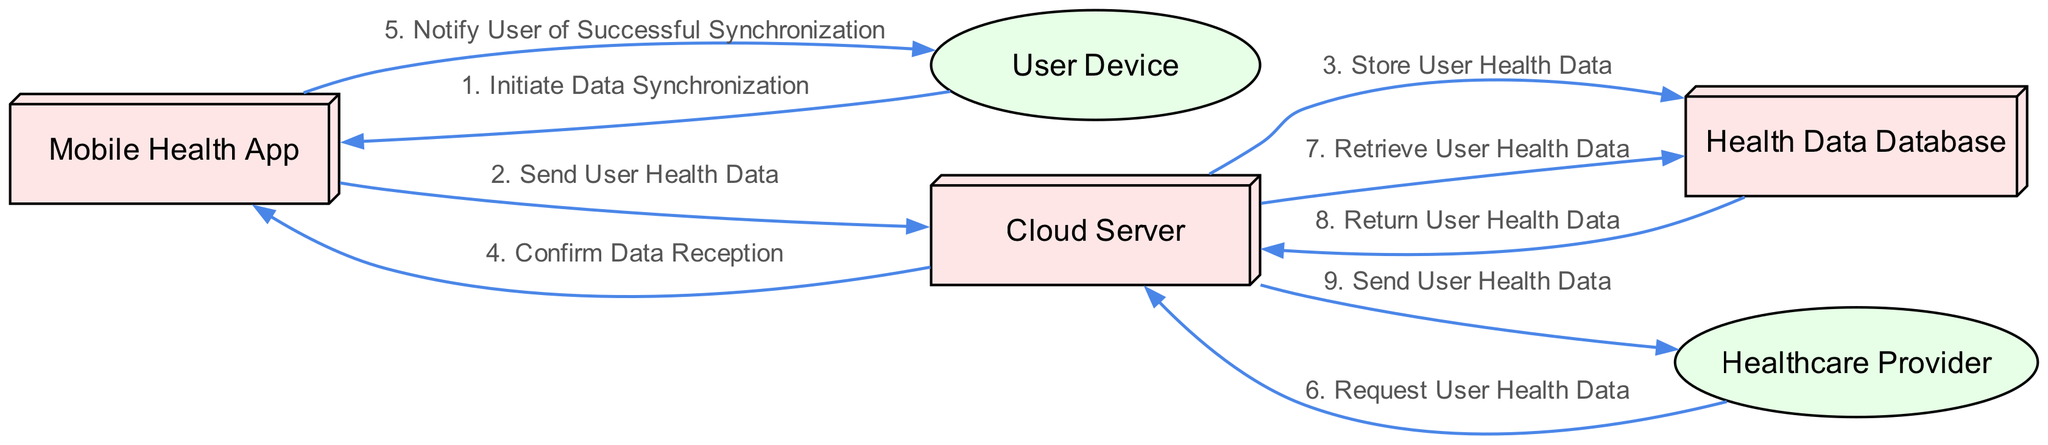What is the first action in the sequence? The first action in the sequence diagram is initiated by the User Device, which is to "Initiate Data Synchronization." This is the starting point of the flow and is the first message in the list.
Answer: Initiate Data Synchronization How many actors are there in the diagram? The diagram includes five actors: Mobile Health App, User Device, Cloud Server, Health Data Database, and Healthcare Provider. Counting them gives a total of five.
Answer: 5 What type of system is the Health Data Database? The Health Data Database is categorized as a "System" type actor in the diagram. This classification is evident from the data provided where actors are described with types.
Answer: System Who sends the User Health Data to the Cloud Server? The Mobile Health App is responsible for sending the User Health Data to the Cloud Server. This relationship is shown in the second message flowing from the Mobile Health App to the Cloud Server.
Answer: Mobile Health App What confirmation action occurs after storing the data? After the Cloud Server stores the User Health Data in the Health Data Database, it sends a confirmation of data reception back to the Mobile Health App. This is the fourth action in the sequence.
Answer: Confirm Data Reception How many messages are exchanged in total? The total number of messages exchanged in the sequence is eight. By counting each message listed in the diagram's structure, we find there are eight unique actions or messages conveyed.
Answer: 8 What does the Cloud Server do upon receiving a request from the Healthcare Provider? Upon receiving a request from the Healthcare Provider, the Cloud Server retrieves the User Health Data from the Health Data Database. This is the flow sequence that follows the request action.
Answer: Retrieve User Health Data Which actor is notified of successful synchronization? The User Device receives the notification of successful synchronization from the Mobile Health App. This step indicates feedback to the user regarding the synchronization process.
Answer: User Device 